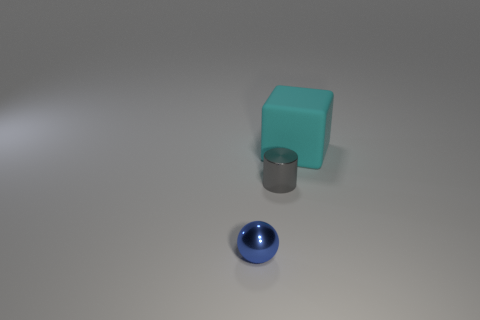Is there anything else that is the same material as the large cube?
Give a very brief answer. No. Are the small thing that is in front of the gray metallic object and the small gray thing made of the same material?
Your response must be concise. Yes. How many spheres are tiny purple metal objects or small blue things?
Offer a very short reply. 1. There is a tiny metallic object that is behind the shiny thing in front of the small object that is right of the blue thing; what shape is it?
Make the answer very short. Cylinder. What number of metal balls have the same size as the cyan matte thing?
Ensure brevity in your answer.  0. There is a tiny thing that is to the right of the tiny blue sphere; are there any small gray metal cylinders that are on the right side of it?
Offer a terse response. No. What number of things are either big green metal cylinders or large matte things?
Your answer should be very brief. 1. The matte block behind the shiny thing that is in front of the tiny thing right of the small blue ball is what color?
Give a very brief answer. Cyan. Is there any other thing of the same color as the shiny ball?
Provide a short and direct response. No. Do the gray cylinder and the rubber block have the same size?
Make the answer very short. No. 